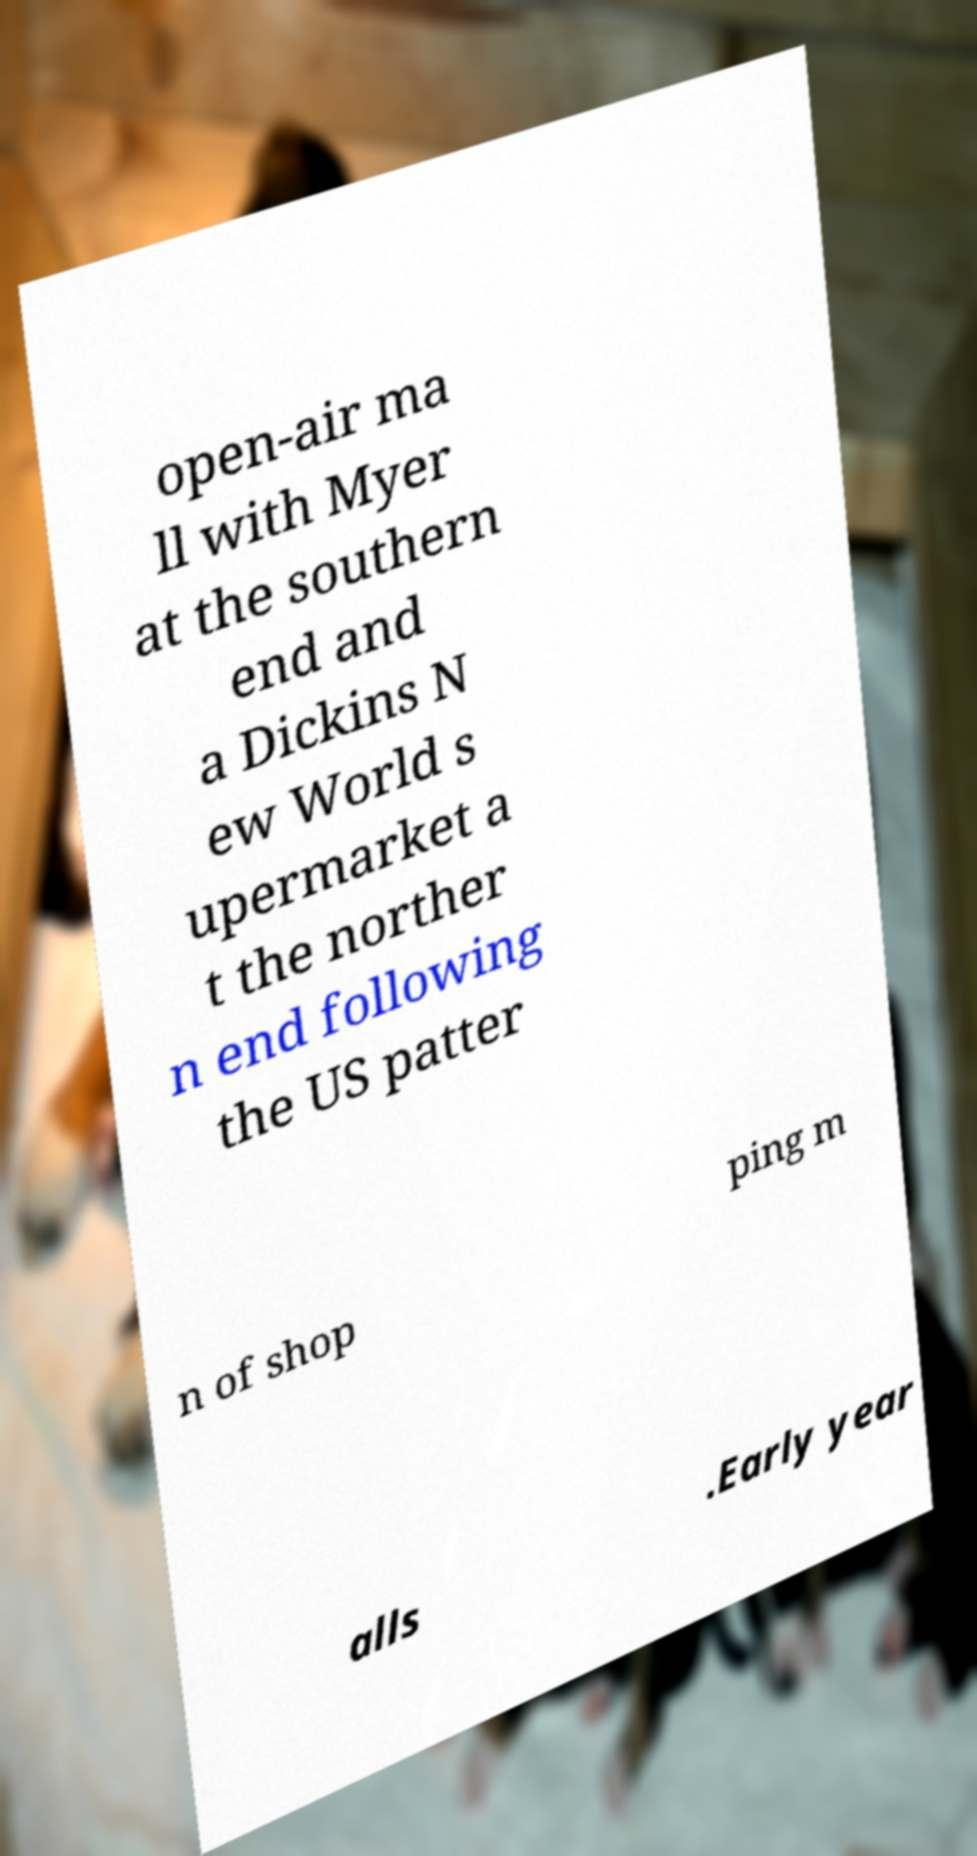Please read and relay the text visible in this image. What does it say? open-air ma ll with Myer at the southern end and a Dickins N ew World s upermarket a t the norther n end following the US patter n of shop ping m alls .Early year 